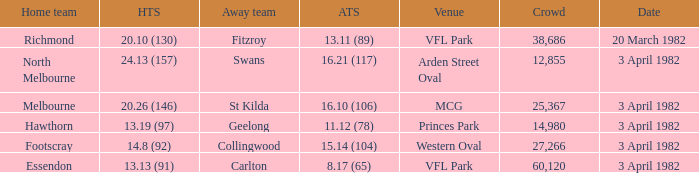What score did the home team of north melbourne get? 24.13 (157). 